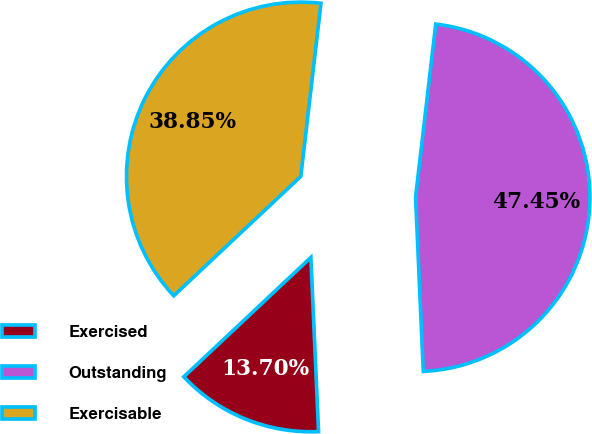<chart> <loc_0><loc_0><loc_500><loc_500><pie_chart><fcel>Exercised<fcel>Outstanding<fcel>Exercisable<nl><fcel>13.7%<fcel>47.45%<fcel>38.85%<nl></chart> 